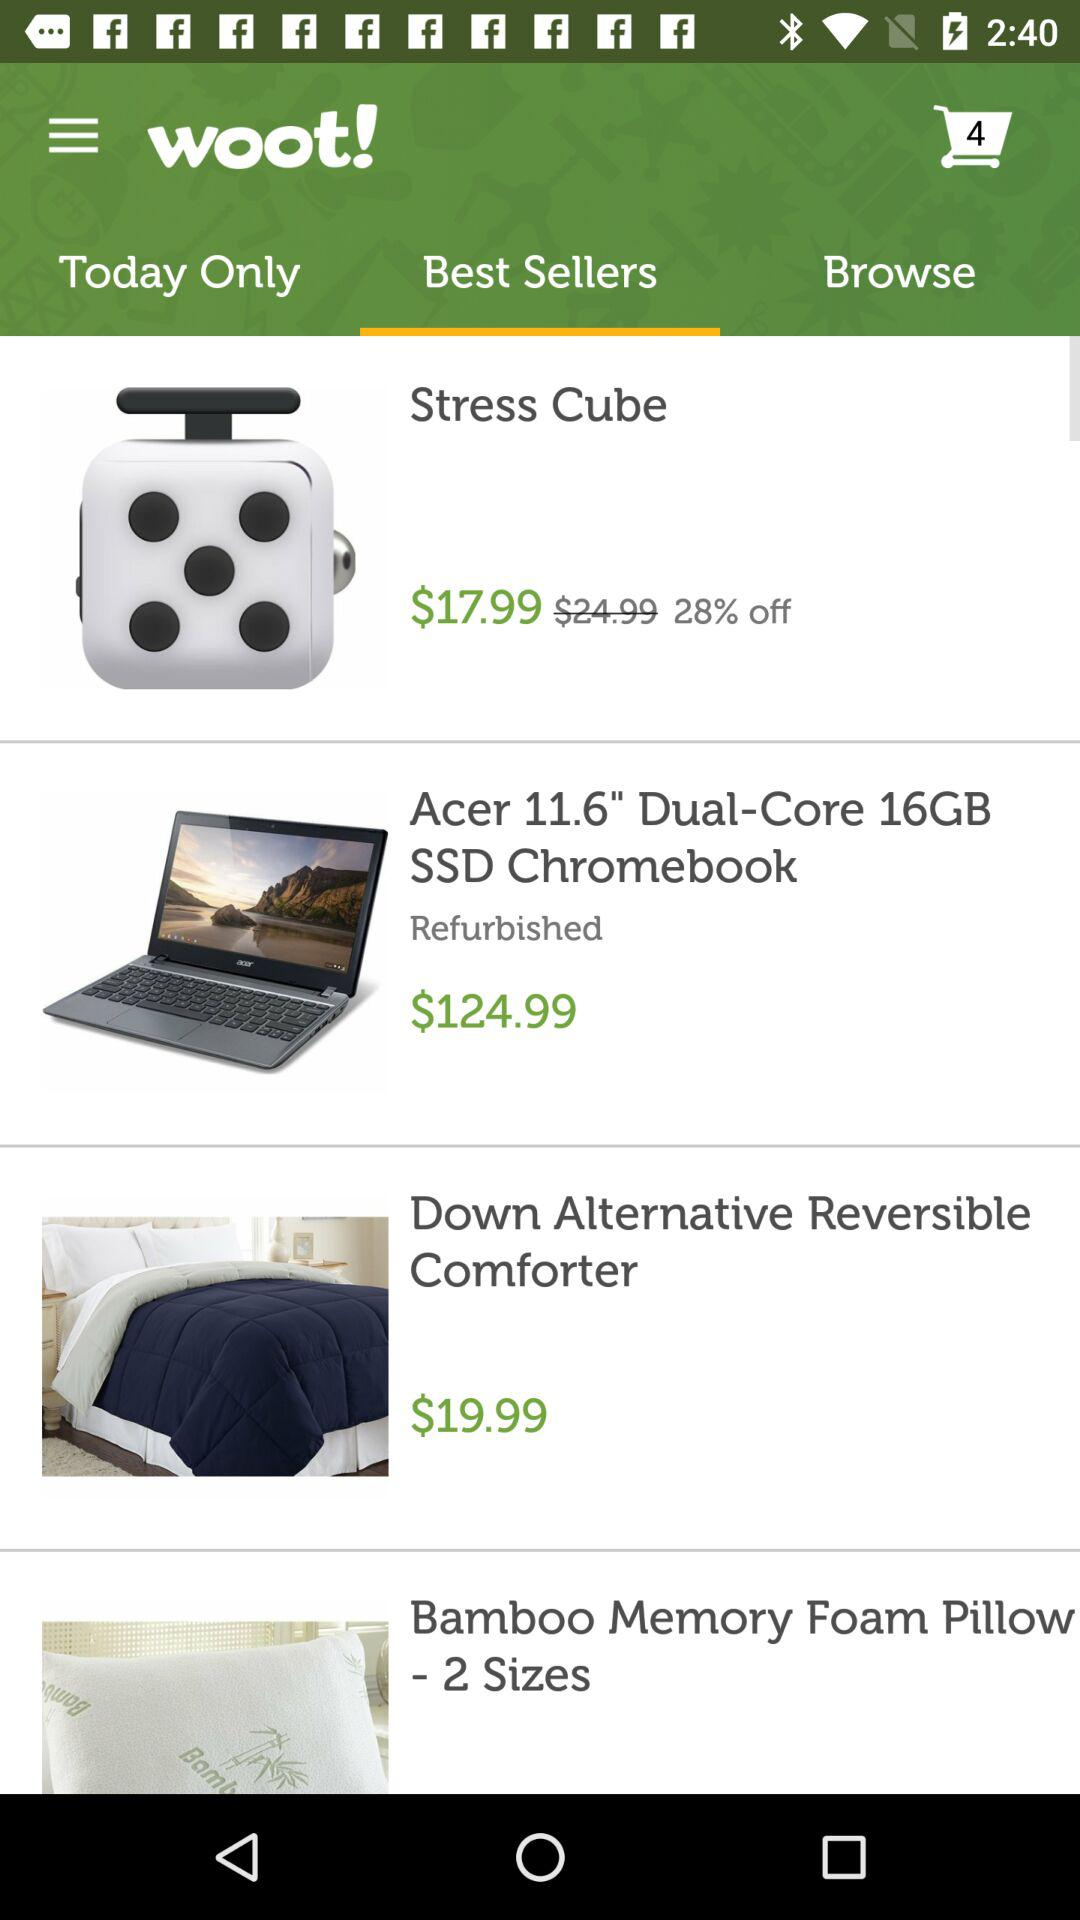What is the price of the "Acer 11.6" Dual-Core 16GB SSD Chromebook"? The price of the Acer Chromebook is $124.99. 